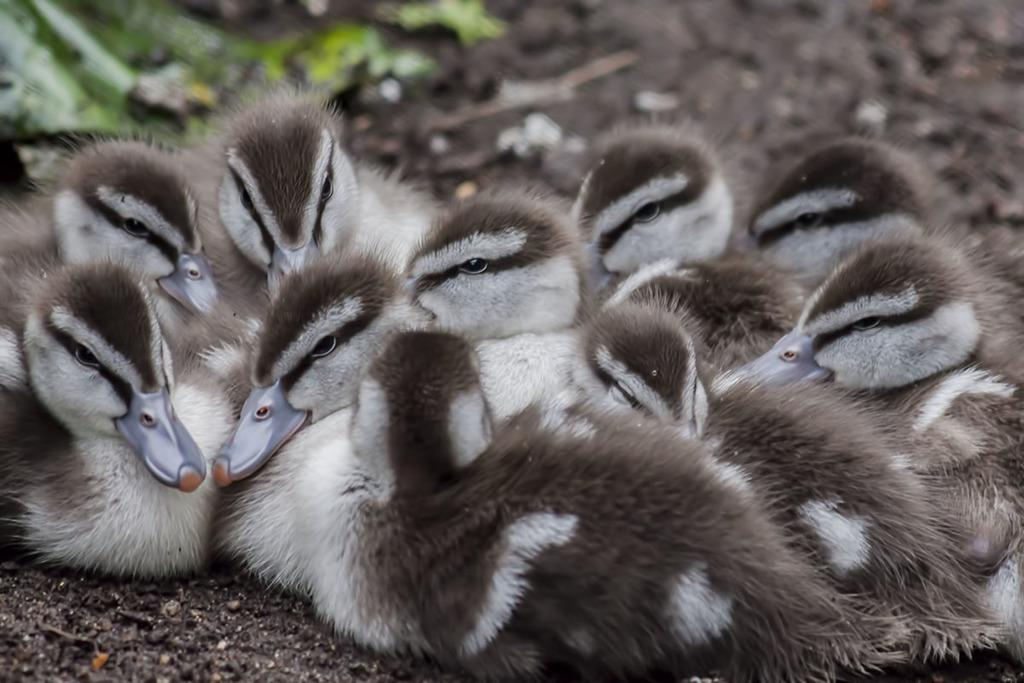What type of animals can be seen in the image? There is a group of birds in the image. Where are the birds located in the image? The birds are on the ground. What type of shoes are the birds wearing in the image? There are no shoes present in the image, as birds do not wear shoes. Can you see a jar filled with pears in the image? There is no jar or pear present in the image; it only features a group of birds on the ground. 